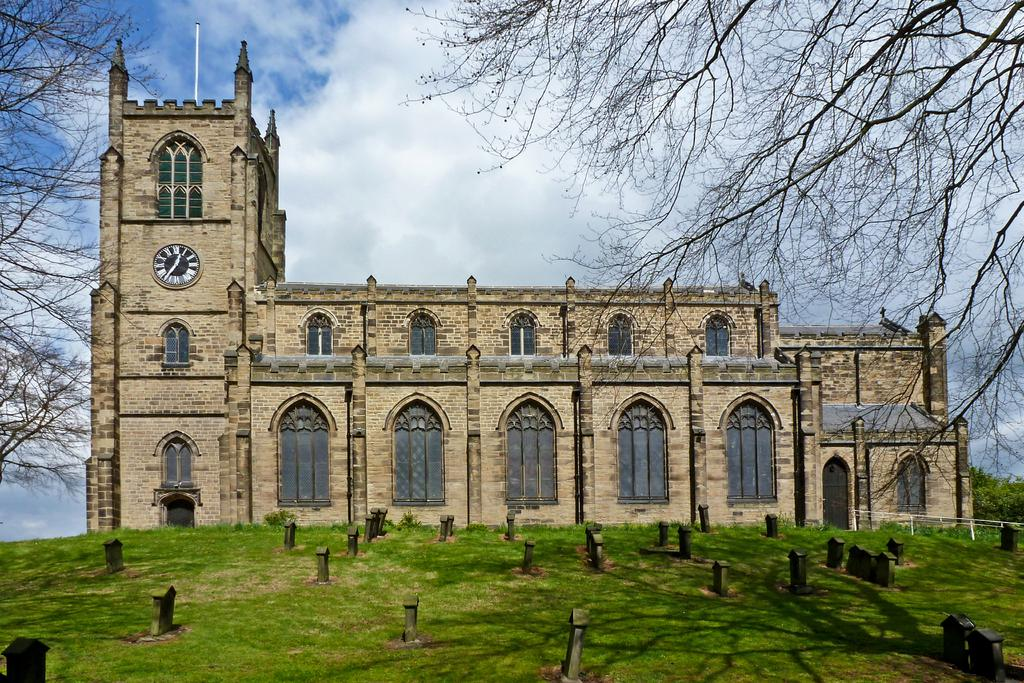What type of location is depicted in the image? There is a graveyard in the image. What other structures can be seen in the image? There is a building in the image. What type of vegetation is present in the image? There is grass and trees in the image. What can be seen in the background of the image? The sky is visible in the background of the image. How many coils are present in the image? There are no coils present in the image. What type of ticket can be seen in the image? There is no ticket present in the image. 